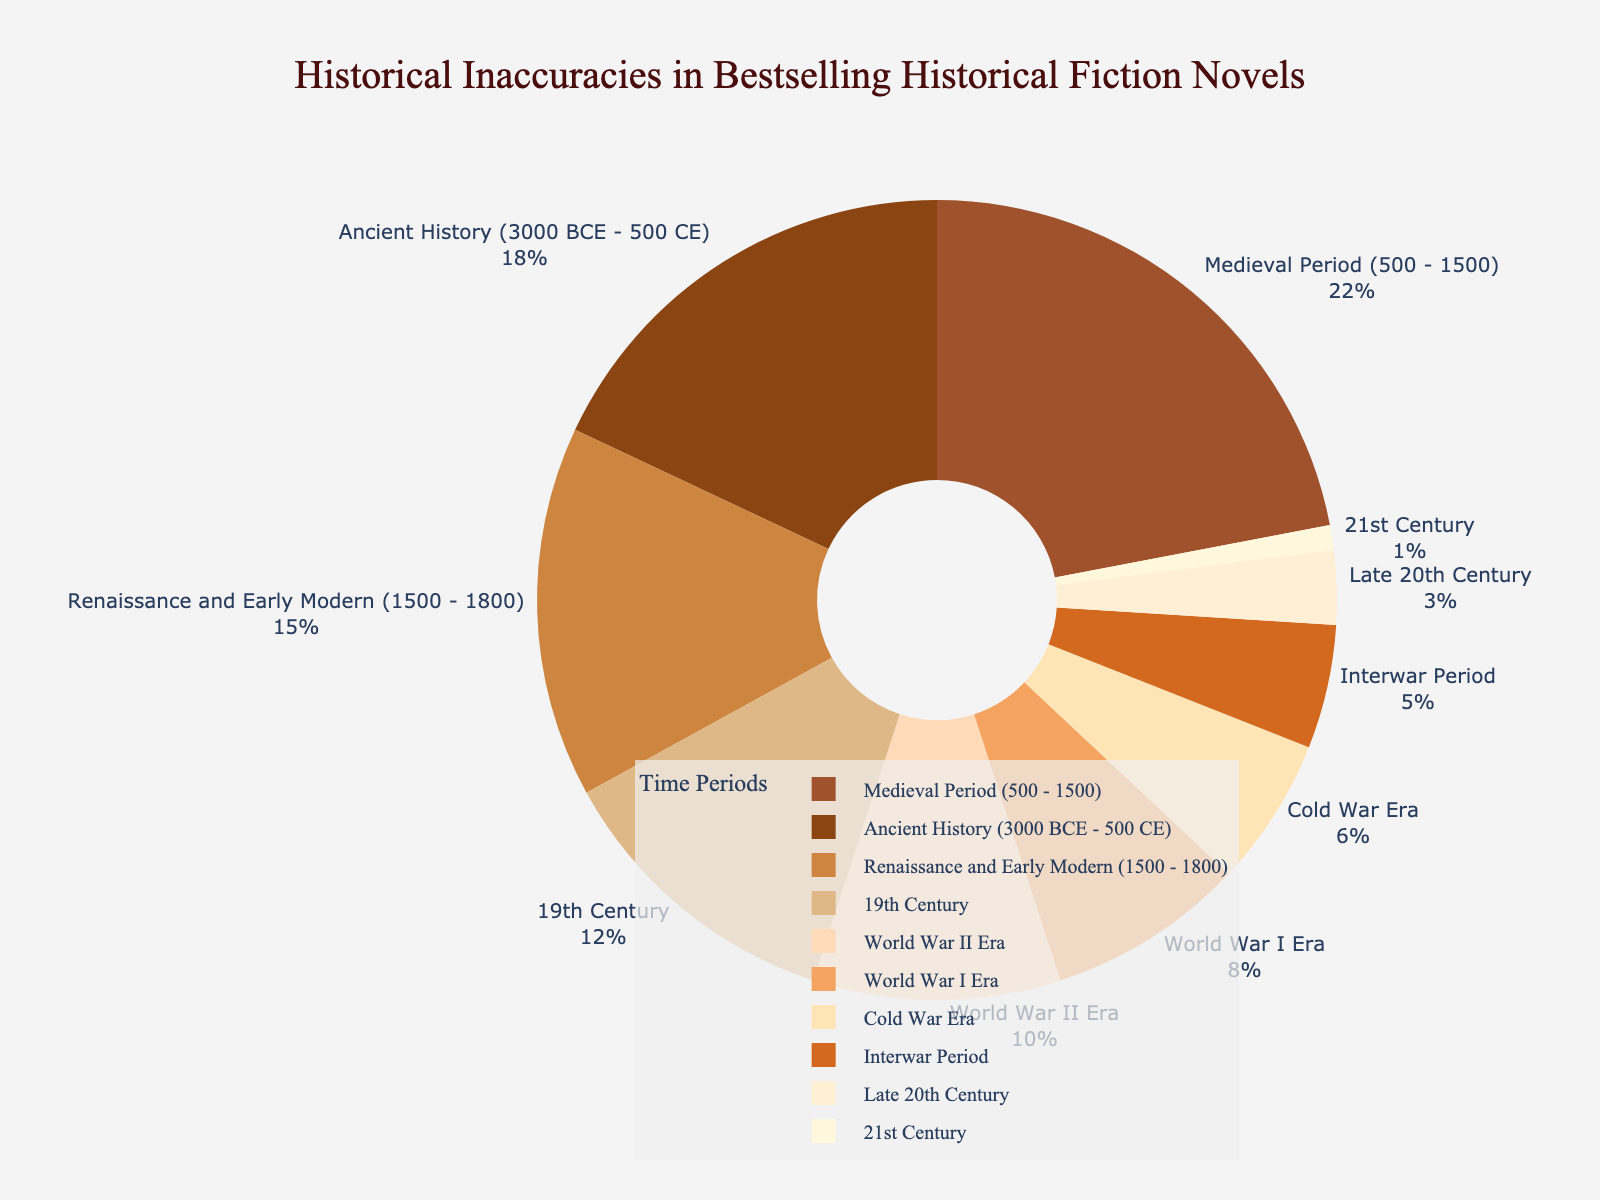What's the largest percentage of inaccuracies, and which time period does it correspond to? The largest percentage of inaccuracies corresponds to the Medieval Period with 22%. By examining the chart, we see Medieval Period has the highest value.
Answer: 22%, Medieval Period Which time period has the fewest inaccuracies? The smallest percentage of inaccuracies is found in the 21st Century period with 1%. The chart shows 21st Century as the smallest segment.
Answer: 1%, 21st Century What is the combined percentage of inaccuracies for the Ancient History and Medieval periods? Adding the percentages of the Ancient History period (18%) and the Medieval period (22%), the sum is 18 + 22 = 40%.
Answer: 40% Which periods collectively represent more than 50% of inaccuracies? Medieval Period (22%) and Ancient History (18%) together constitute 40%. Adding Renaissance and Early Modern Period (15%), it equals 55%, which is more than 50%.
Answer: Medieval Period, Ancient History, Renaissance and Early Modern Compare the World War I Era with the World War II Era in terms of inaccuracies. Which one has more, and by how much? The percentage for World War I Era is 8% and World War II Era is 10%. The difference is 10 - 8 = 2%. Therefore, World War II Era has 2% more inaccuracies.
Answer: World War II Era, 2% What is the average percentage of inaccuracies for the 19th Century, World War I Era, and Cold War Era? The 19th Century has 12%, World War I Era 8%, and Cold War Era 6%. The sum of these percentages is 12 + 8 + 6 = 26. The average is 26 / 3 ≈ 8.67%.
Answer: 8.67% Arrange the time periods from highest to lowest percentage of inaccuracies using visual inspection. By looking at the chart, the order from highest to lowest percentage of inaccuracies is: Medieval Period (22%), Ancient History (18%), Renaissance and Early Modern (15%), 19th Century (12%), World War II Era (10%), World War I Era (8%), Cold War Era (6%), Interwar Period (5%), Late 20th Century (3%), 21st Century (1%).
Answer: Medieval Period, Ancient History, Renaissance and Early Modern, 19th Century, World War II Era, World War I Era, Cold War Era, Interwar Period, Late 20th Century, 21st Century What is the combined percentage of inaccuracies for the periods after the World War II Era? Adding the percentages of Cold War Era (6%), Late 20th Century (3%), and 21st Century (1%) gives us a total of 6 + 3 + 1 = 10%.
Answer: 10% Which segment of the pie chart is represented by light colors (beige shades)? The Interwar Period, World War I Era, World War II Era, Cold War Era, Late 20th Century, and 21st Century are represented by light, beige shades of the pie chart based on the color scale used.
Answer: Interwar Period, World War I Era, World War II Era, Cold War Era, Late 20th Century, 21st Century 